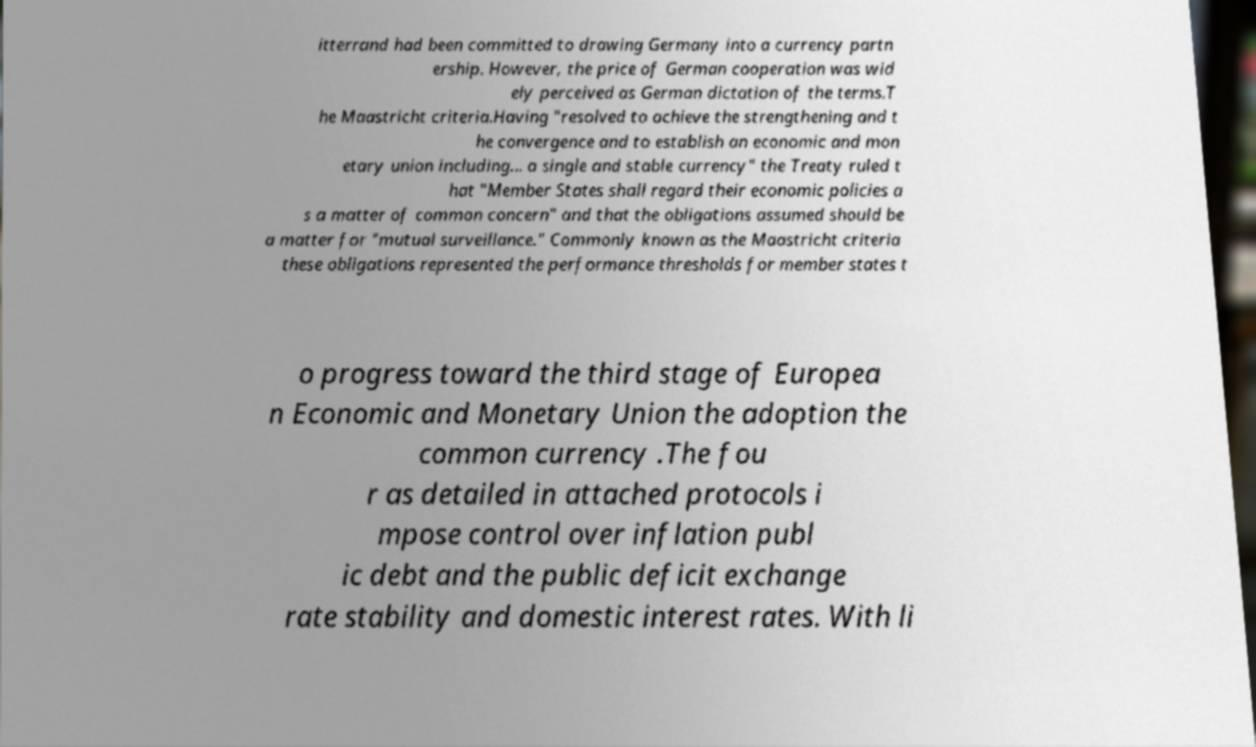Can you accurately transcribe the text from the provided image for me? itterrand had been committed to drawing Germany into a currency partn ership. However, the price of German cooperation was wid ely perceived as German dictation of the terms.T he Maastricht criteria.Having "resolved to achieve the strengthening and t he convergence and to establish an economic and mon etary union including... a single and stable currency" the Treaty ruled t hat "Member States shall regard their economic policies a s a matter of common concern" and that the obligations assumed should be a matter for "mutual surveillance." Commonly known as the Maastricht criteria these obligations represented the performance thresholds for member states t o progress toward the third stage of Europea n Economic and Monetary Union the adoption the common currency .The fou r as detailed in attached protocols i mpose control over inflation publ ic debt and the public deficit exchange rate stability and domestic interest rates. With li 